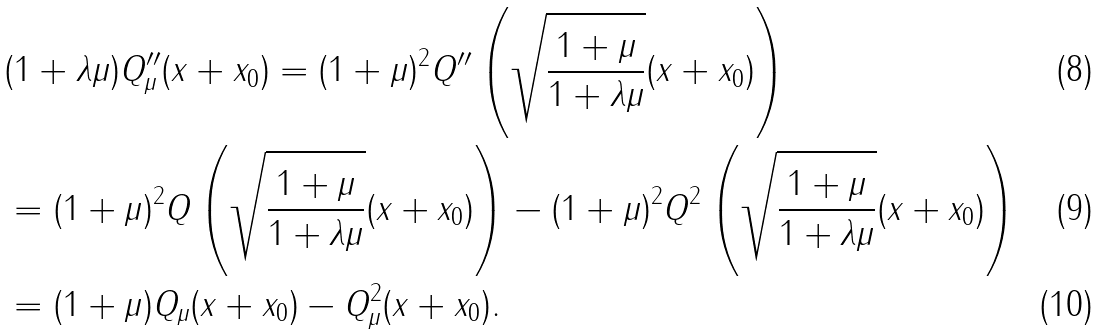Convert formula to latex. <formula><loc_0><loc_0><loc_500><loc_500>& ( 1 + \lambda \mu ) Q _ { \mu } ^ { \prime \prime } ( x + x _ { 0 } ) = ( 1 + \mu ) ^ { 2 } Q ^ { \prime \prime } \left ( \sqrt { \frac { 1 + \mu } { 1 + \lambda \mu } } ( x + x _ { 0 } ) \right ) \\ & = ( 1 + \mu ) ^ { 2 } Q \left ( \sqrt { \frac { 1 + \mu } { 1 + \lambda \mu } } ( x + x _ { 0 } ) \right ) - ( 1 + \mu ) ^ { 2 } Q ^ { 2 } \left ( \sqrt { \frac { 1 + \mu } { 1 + \lambda \mu } } ( x + x _ { 0 } ) \right ) \\ & = ( 1 + \mu ) Q _ { \mu } ( x + x _ { 0 } ) - Q _ { \mu } ^ { 2 } ( x + x _ { 0 } ) .</formula> 